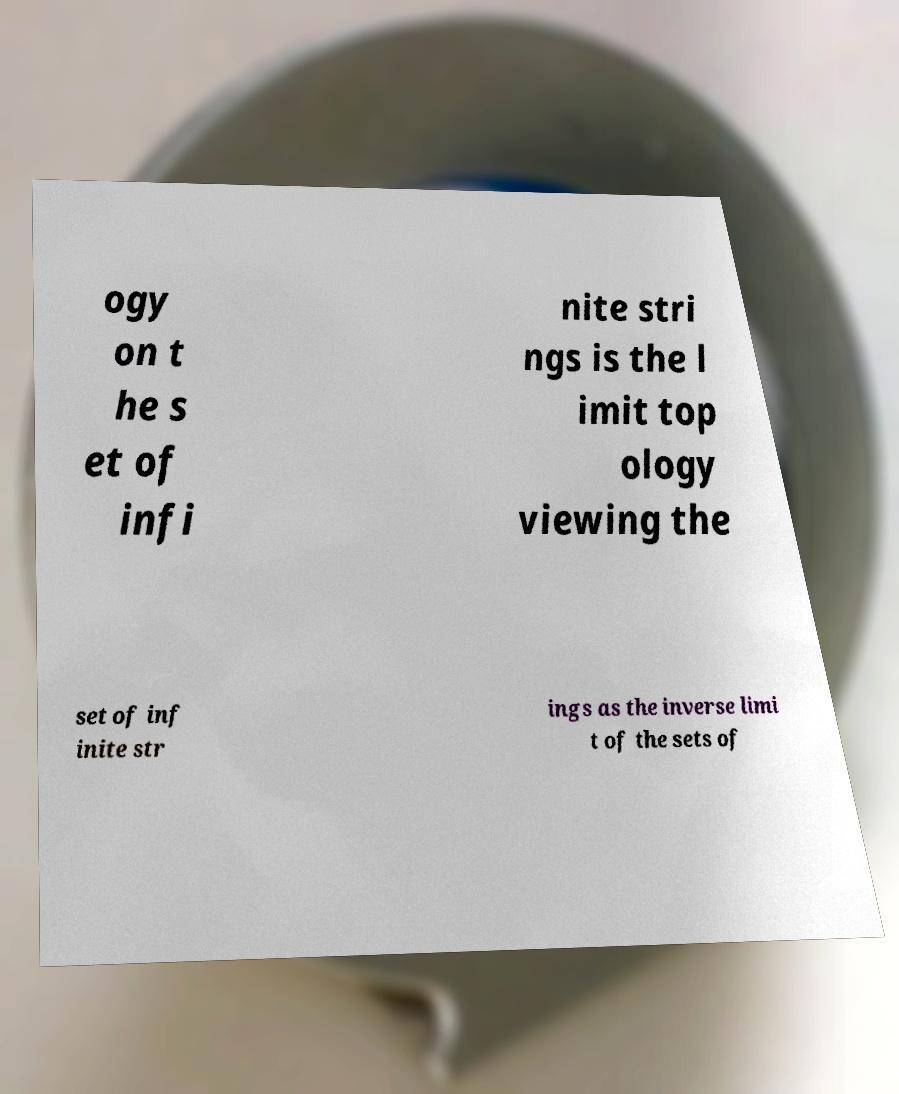What messages or text are displayed in this image? I need them in a readable, typed format. ogy on t he s et of infi nite stri ngs is the l imit top ology viewing the set of inf inite str ings as the inverse limi t of the sets of 